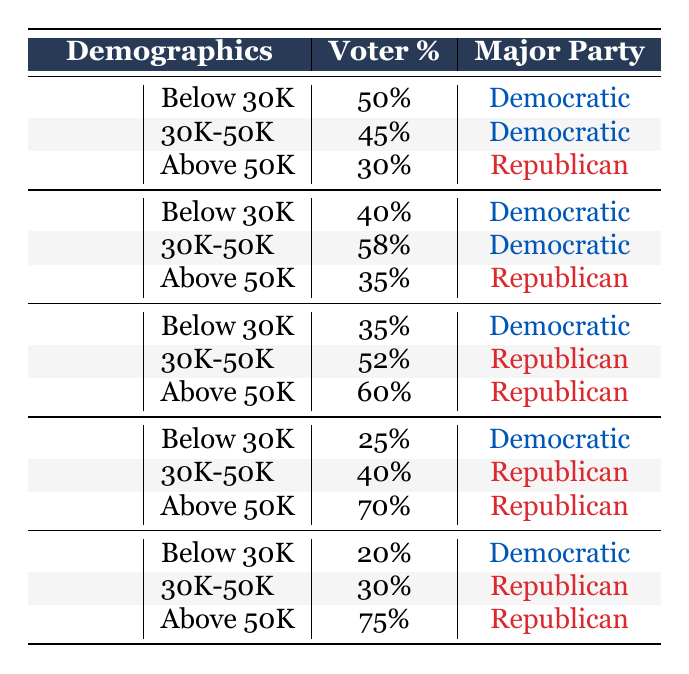What percentage of 18-24-year-olds earning above 50K voted Republican? According to the table, 30% of 18-24-year-olds in the income bracket above 50K voted Republican.
Answer: 30% Which age group had the highest percentage of voters for the Democratic Party in the Below 30K income bracket? The 18-24 age group had 50% of voters supporting the Democratic Party in the Below 30K income bracket, which is higher than the other age groups listed.
Answer: 18-24 What is the combined percentage of Republican voters across all income brackets for the 35-49 age group? In the 35-49 age group, the Republican percentages are 52% (30K-50K) and 60% (Above 50K). Adding these gives 52 + 60 = 112%. Note that this does not include Below 30K since it is Democratic.
Answer: 112% Is it true that individuals aged 65+ lean more Democratic in all income brackets? No, the table shows that in the Below 30K bracket, 20% voted Democratic, but in both the 30K-50K and Above 50K brackets, the majority (30% and 75% respectively) voted Republican.
Answer: No What is the difference in voter percentage between Republican voters in the 50-64 age group earning above 50K and the 65+ age group in the same income bracket? For the 50-64 age group earning above 50K, the percentage of Republican voters is 70%. For the 65+ age group, it’s 75%. The difference is 75 - 70 = 5%.
Answer: 5% 